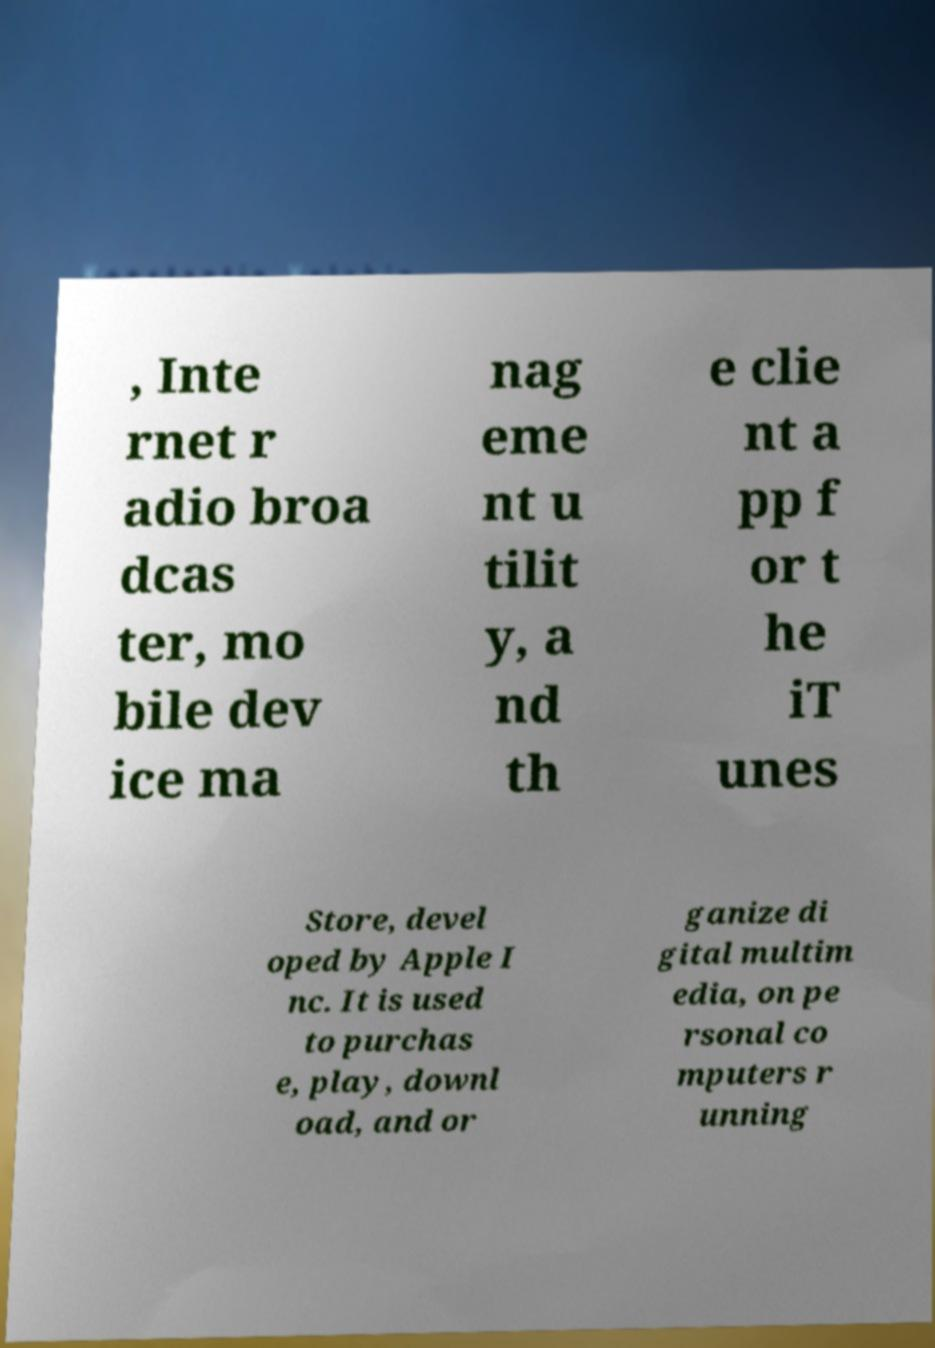Could you assist in decoding the text presented in this image and type it out clearly? , Inte rnet r adio broa dcas ter, mo bile dev ice ma nag eme nt u tilit y, a nd th e clie nt a pp f or t he iT unes Store, devel oped by Apple I nc. It is used to purchas e, play, downl oad, and or ganize di gital multim edia, on pe rsonal co mputers r unning 